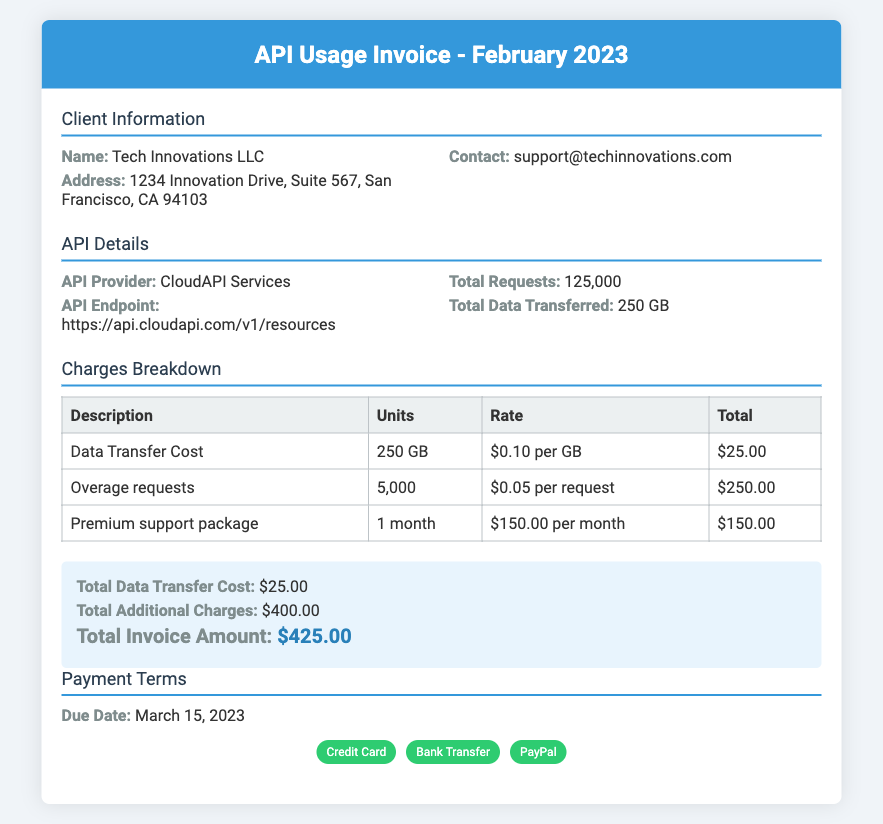What is the total number of requests? The total number of requests is provided in the API Details section of the document.
Answer: 125,000 What is the total data transferred? The total data transferred is mentioned in the API Details section of the document.
Answer: 250 GB What is the due date for the payment? The due date for the payment is stated in the Payment Terms section of the document.
Answer: March 15, 2023 What is the charge for the premium support package? The charge for the premium support package is outlined in the Charges Breakdown table of the document.
Answer: $150.00 What is the total invoice amount? The total invoice amount is summarized in the Charges Breakdown section of the document.
Answer: $425.00 How much is charged per GB for data transfer? The charge per GB for data transfer is listed in the Charges Breakdown section of the document.
Answer: $0.10 per GB How many overage requests were made? The number of overage requests is provided in the Charges Breakdown table of the document.
Answer: 5,000 What is the total additional charges? The total additional charges are stated in the summary section of the document.
Answer: $400.00 What is the API provider's name? The API provider's name is mentioned in the API Details section of the document.
Answer: CloudAPI Services 